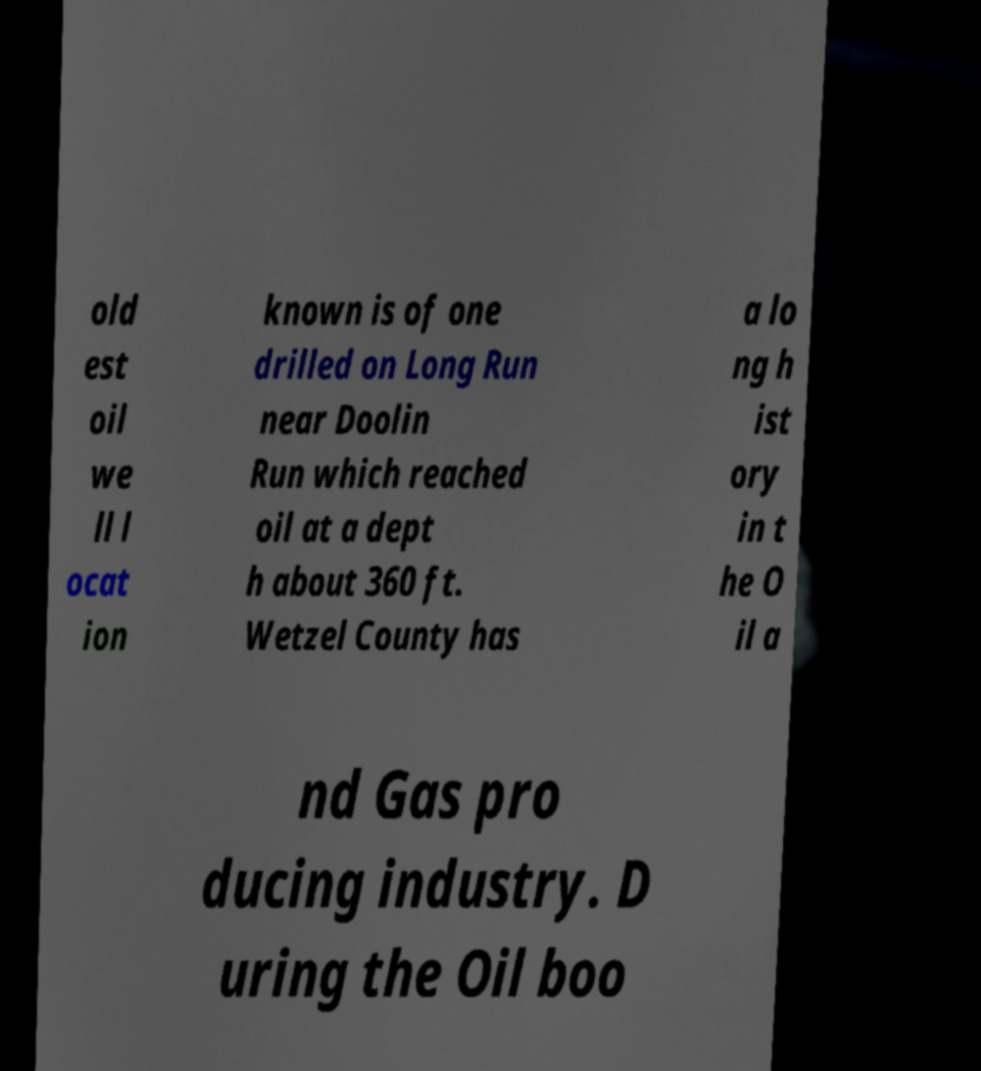Please identify and transcribe the text found in this image. old est oil we ll l ocat ion known is of one drilled on Long Run near Doolin Run which reached oil at a dept h about 360 ft. Wetzel County has a lo ng h ist ory in t he O il a nd Gas pro ducing industry. D uring the Oil boo 